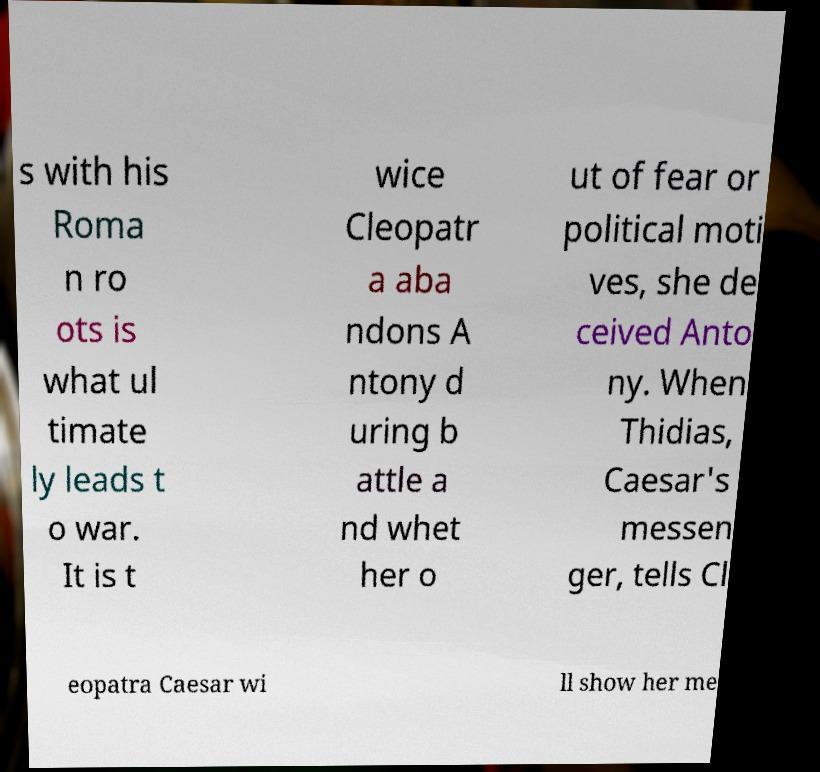Could you extract and type out the text from this image? s with his Roma n ro ots is what ul timate ly leads t o war. It is t wice Cleopatr a aba ndons A ntony d uring b attle a nd whet her o ut of fear or political moti ves, she de ceived Anto ny. When Thidias, Caesar's messen ger, tells Cl eopatra Caesar wi ll show her me 